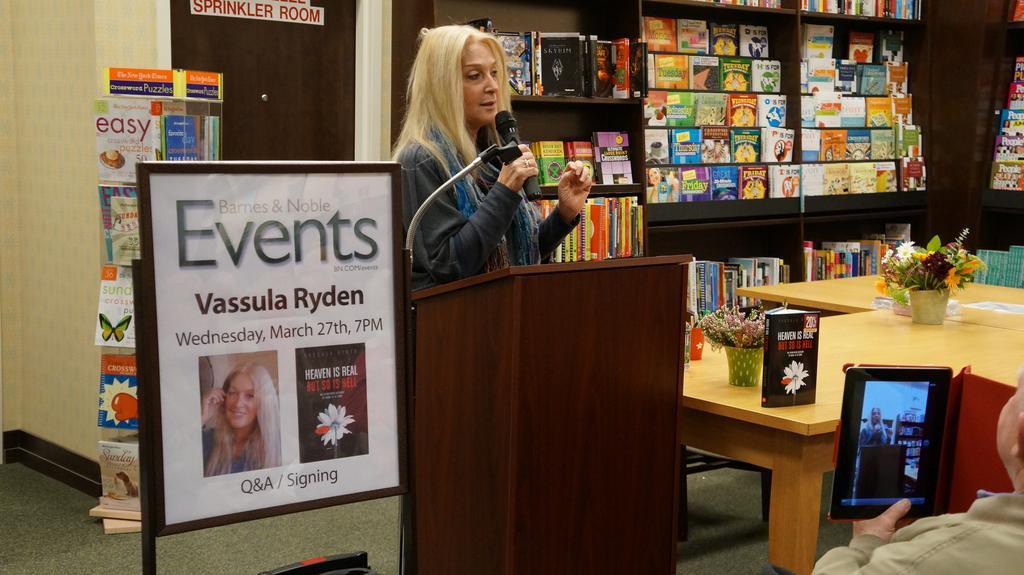Could you give a brief overview of what you see in this image? In this image I can see a woman standing in front of the podium. The woman is holding the mic. On the left side there is board. On the right side there is a table. On the table there is a book and a small flower plant. At the back side there are book racks and a book shelf. In front of the woman the person is holding a tab. On the left side there is a door. 